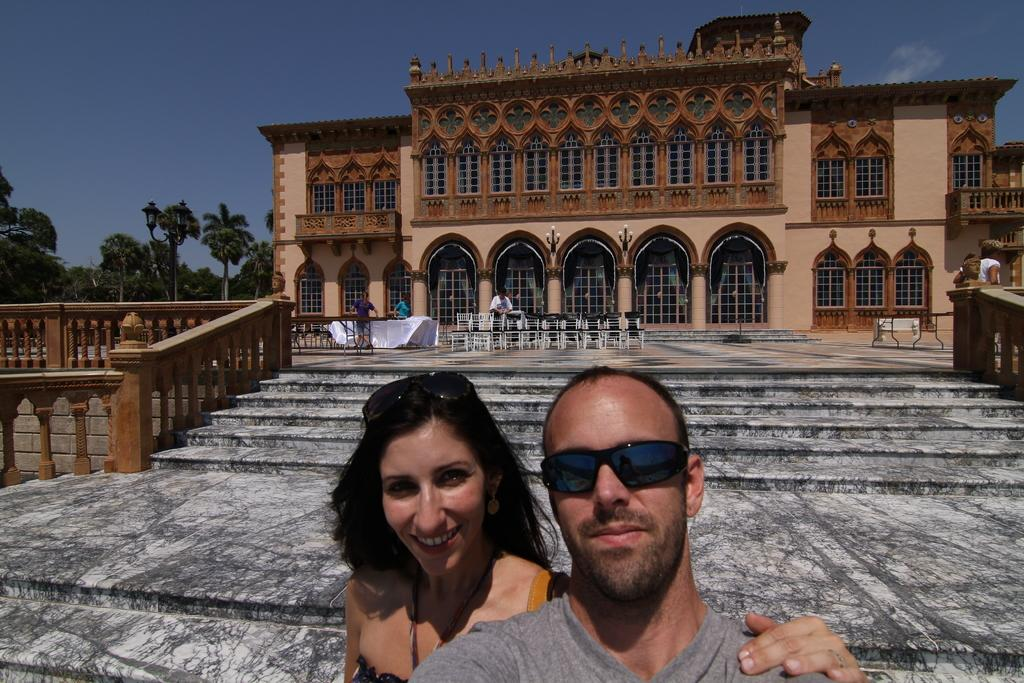Who or what can be seen in the image? There are people in the image. What type of furniture is present in the image? There are tables and chairs in the image. What architectural feature is visible at the bottom of the image? There are stairs at the bottom of the image. What can be seen in the background of the image? There are trees, sky, and a building visible in the background of the image. How many oranges are being held by the people in the image? There are no oranges present in the image. Can you describe the interaction between the cows and the people in the image? There are no cows present in the image. 